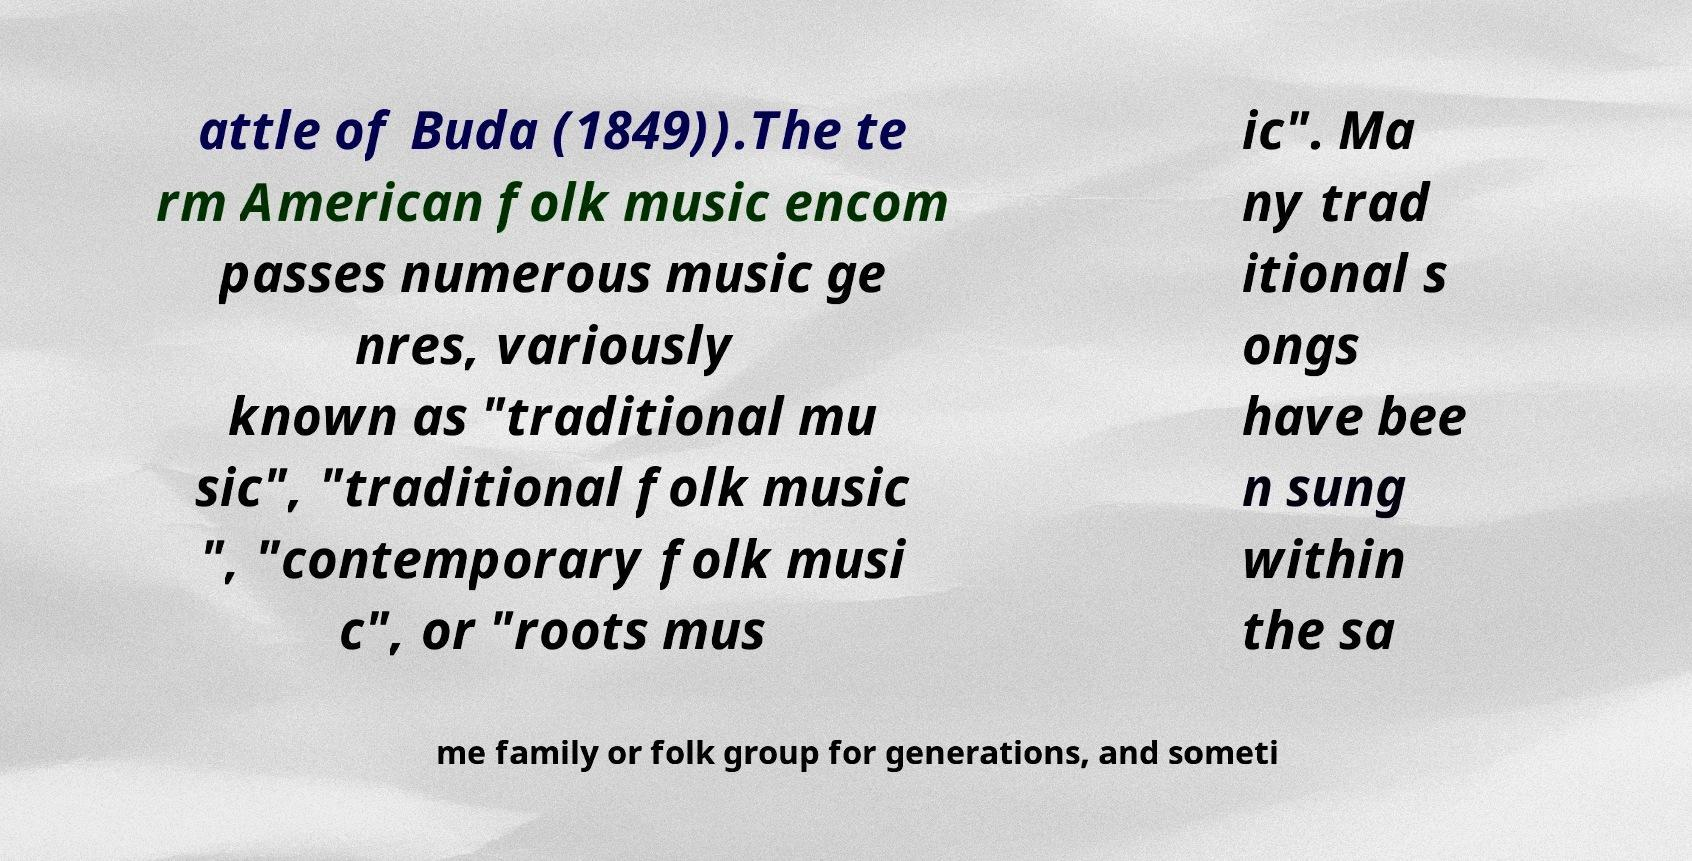There's text embedded in this image that I need extracted. Can you transcribe it verbatim? attle of Buda (1849)).The te rm American folk music encom passes numerous music ge nres, variously known as "traditional mu sic", "traditional folk music ", "contemporary folk musi c", or "roots mus ic". Ma ny trad itional s ongs have bee n sung within the sa me family or folk group for generations, and someti 